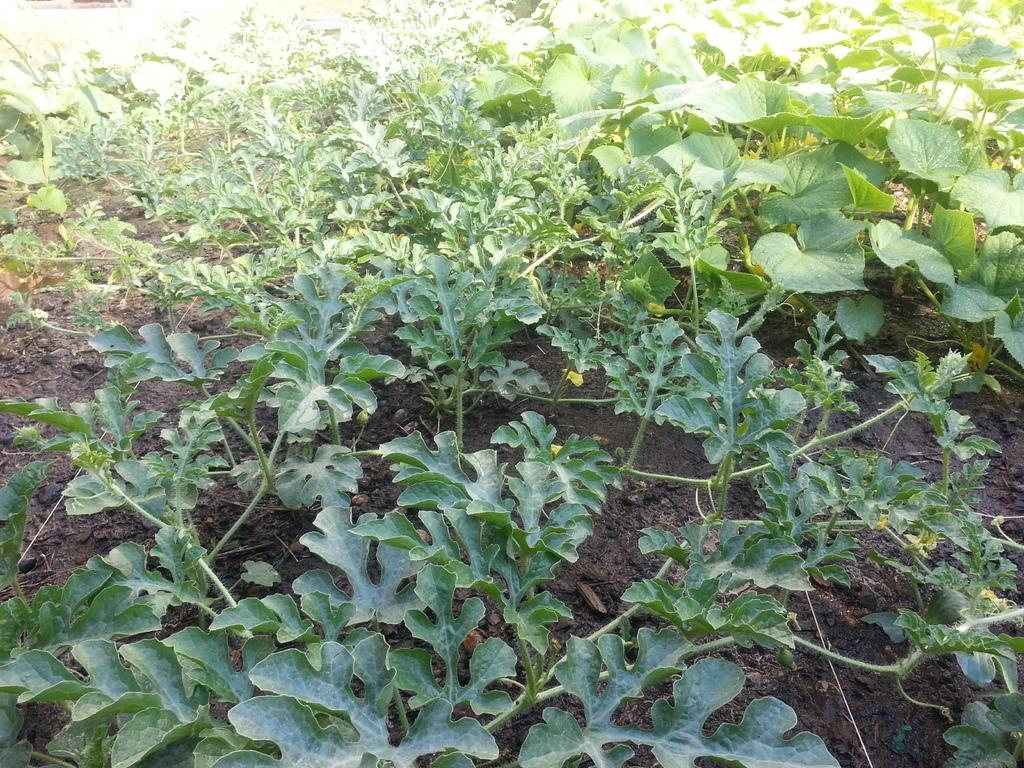What type of plants can be seen in the image? There are plants with green leaves in the image. What is the condition of the soil in the image? There is mud visible in the image. What type of calculator is being used to measure the plants in the image? There is no calculator present in the image. Can you see any bombs in the image? There are no bombs present in the image. 